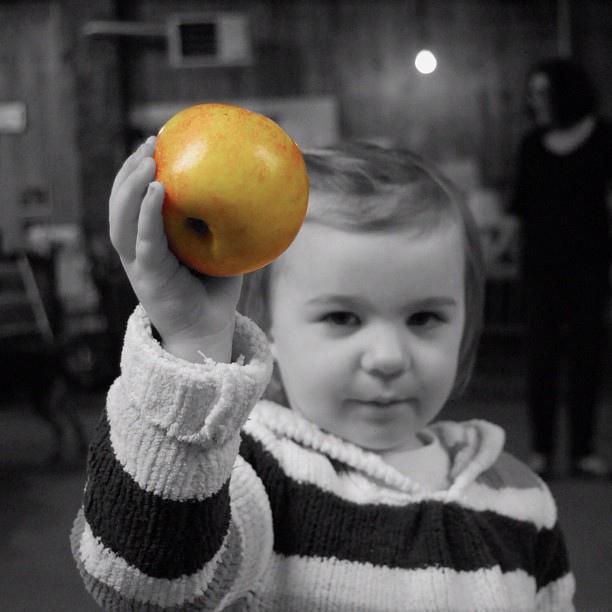What happens to the image?
Pick the right solution, then justify: 'Answer: answer
Rationale: rationale.'
Options: Blurred, too bright, too dark, photoshopped. Answer: photoshopped.
Rationale: The image has emphasized the apple with photoshop. 